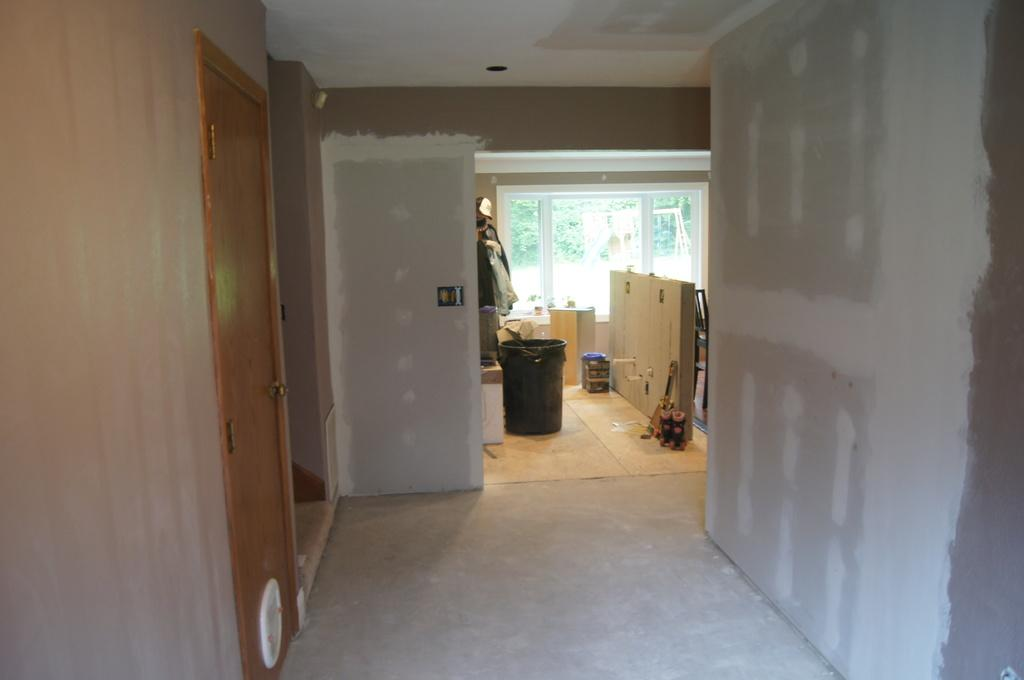What type of entryways are present in the image? There are doors in the image. What is located on the floor in the image? There is a bucket on the floor in the image, as well as other objects. What type of transparent barrier is present in the image? There is a glass window in the image. What can be seen through the glass window in the background of the image? Trees are visible through the glass windows in the background of the image. What is the price of the fork in the image? There is no fork present in the image, so it is not possible to determine its price. 